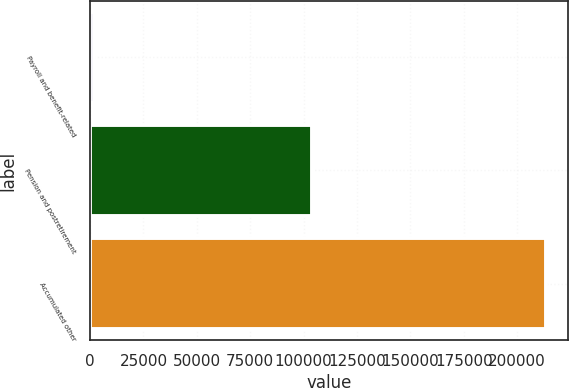Convert chart. <chart><loc_0><loc_0><loc_500><loc_500><bar_chart><fcel>Payroll and benefit-related<fcel>Pension and postretirement<fcel>Accumulated other<nl><fcel>1653<fcel>104132<fcel>213301<nl></chart> 